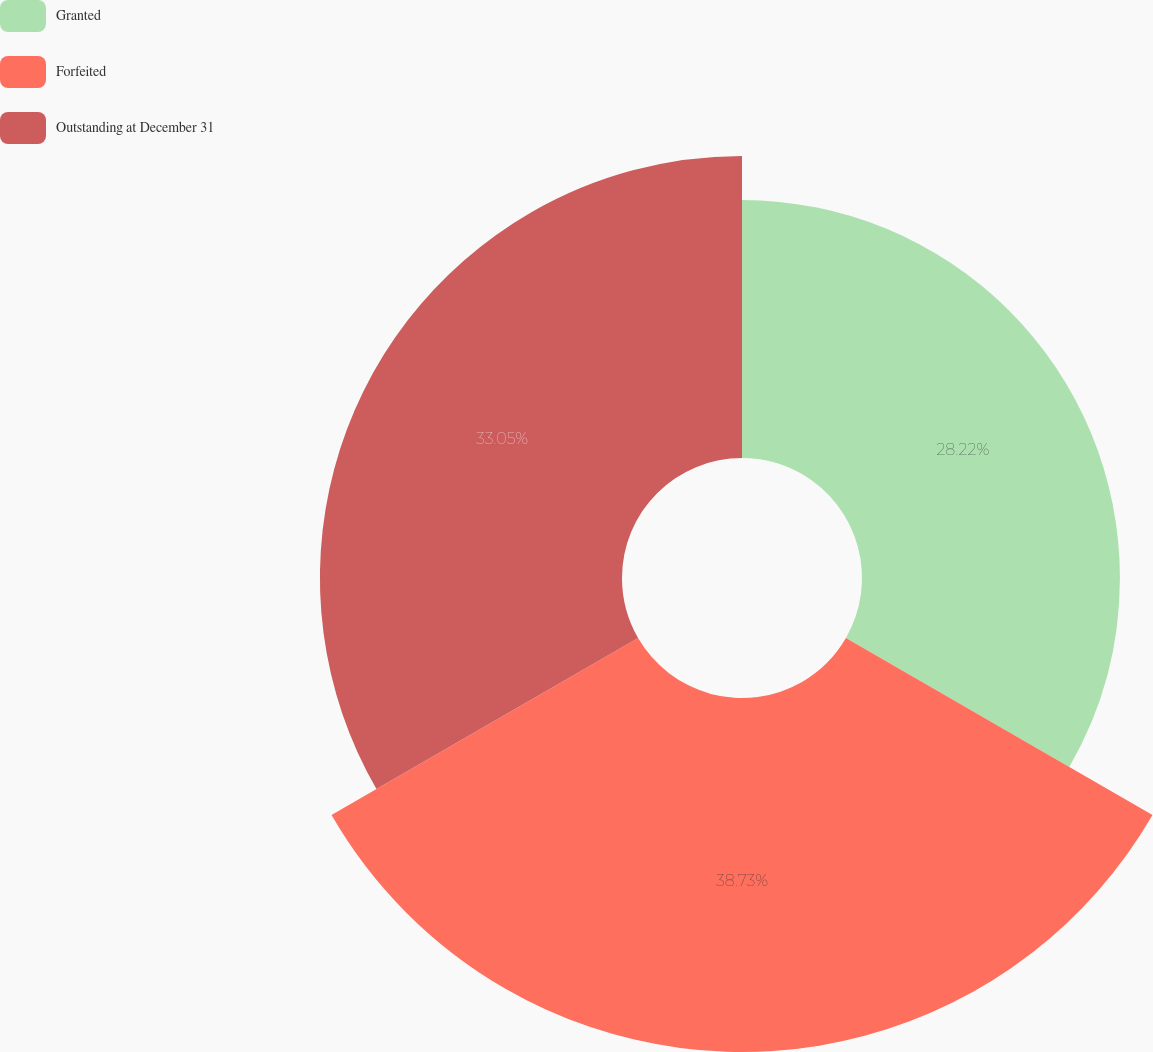<chart> <loc_0><loc_0><loc_500><loc_500><pie_chart><fcel>Granted<fcel>Forfeited<fcel>Outstanding at December 31<nl><fcel>28.22%<fcel>38.73%<fcel>33.05%<nl></chart> 